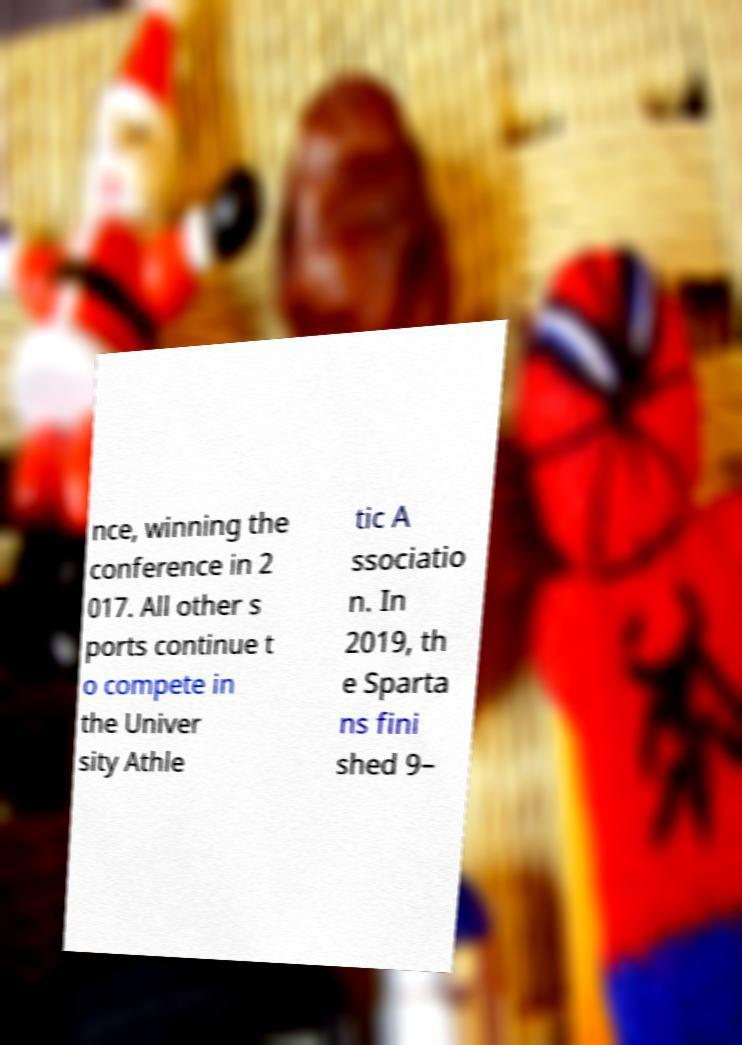For documentation purposes, I need the text within this image transcribed. Could you provide that? nce, winning the conference in 2 017. All other s ports continue t o compete in the Univer sity Athle tic A ssociatio n. In 2019, th e Sparta ns fini shed 9– 